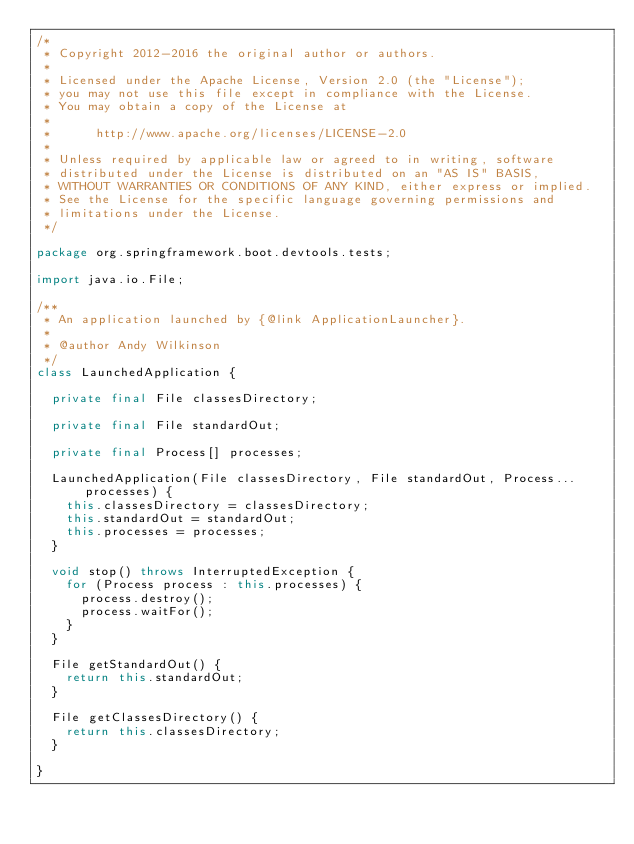Convert code to text. <code><loc_0><loc_0><loc_500><loc_500><_Java_>/*
 * Copyright 2012-2016 the original author or authors.
 *
 * Licensed under the Apache License, Version 2.0 (the "License");
 * you may not use this file except in compliance with the License.
 * You may obtain a copy of the License at
 *
 *      http://www.apache.org/licenses/LICENSE-2.0
 *
 * Unless required by applicable law or agreed to in writing, software
 * distributed under the License is distributed on an "AS IS" BASIS,
 * WITHOUT WARRANTIES OR CONDITIONS OF ANY KIND, either express or implied.
 * See the License for the specific language governing permissions and
 * limitations under the License.
 */

package org.springframework.boot.devtools.tests;

import java.io.File;

/**
 * An application launched by {@link ApplicationLauncher}.
 *
 * @author Andy Wilkinson
 */
class LaunchedApplication {

	private final File classesDirectory;

	private final File standardOut;

	private final Process[] processes;

	LaunchedApplication(File classesDirectory, File standardOut, Process... processes) {
		this.classesDirectory = classesDirectory;
		this.standardOut = standardOut;
		this.processes = processes;
	}

	void stop() throws InterruptedException {
		for (Process process : this.processes) {
			process.destroy();
			process.waitFor();
		}
	}

	File getStandardOut() {
		return this.standardOut;
	}

	File getClassesDirectory() {
		return this.classesDirectory;
	}

}
</code> 